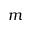<formula> <loc_0><loc_0><loc_500><loc_500>m</formula> 